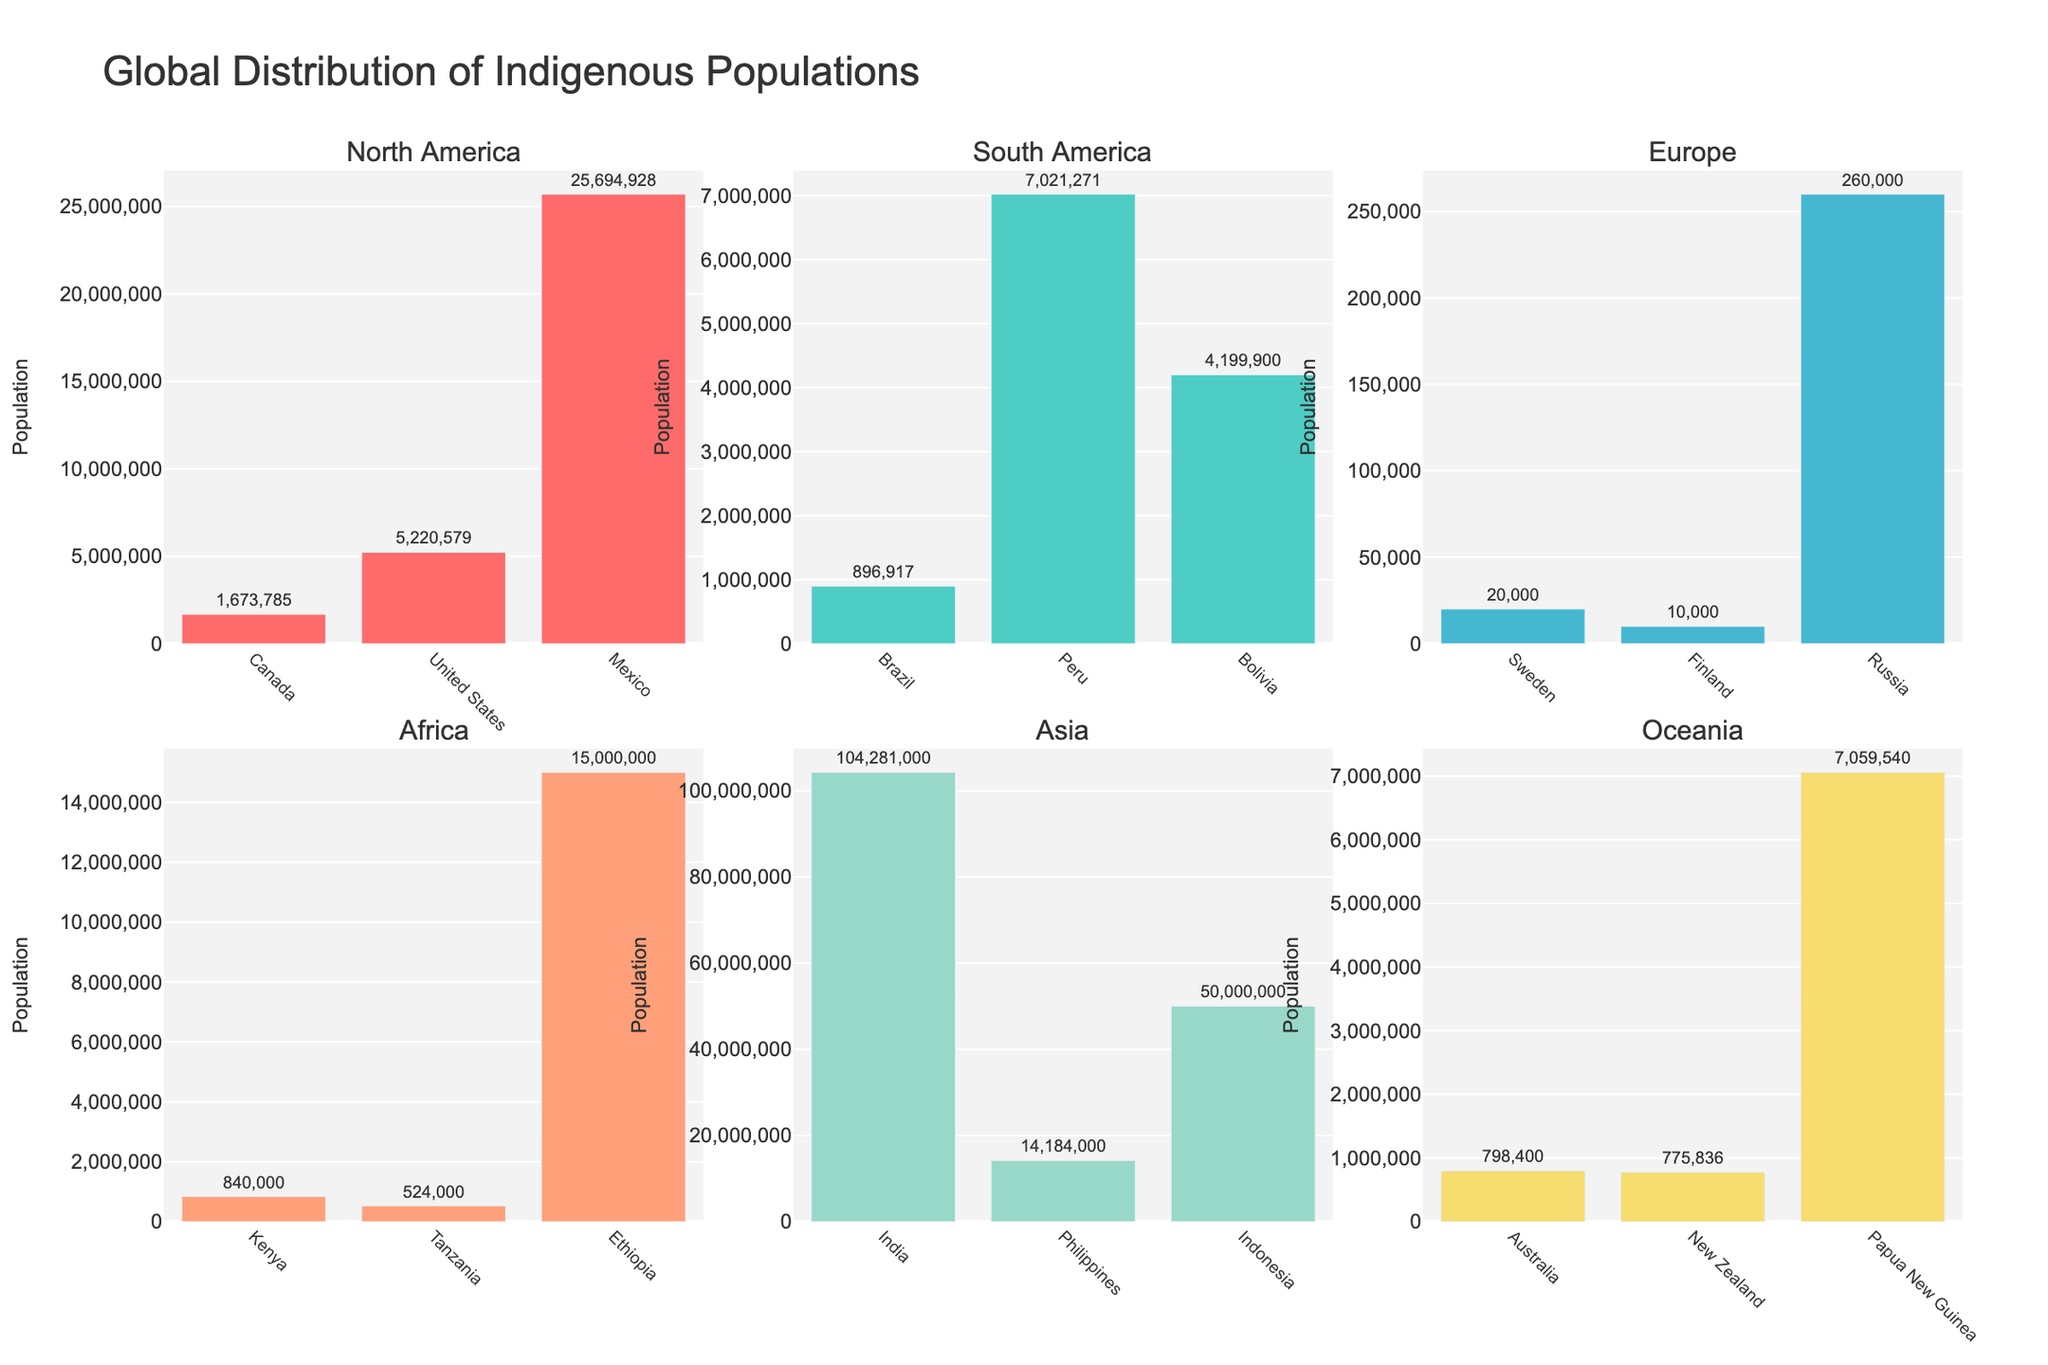What is the title of the figure? The title of the figure is usually found at the top and provides an overview of what the plot represents. In this case, the title is "Magical Realism Theater Productions Analysis".
Answer: Magical Realism Theater Productions Analysis How many productions are shown in the scatter plot? Each marker in the scatter plot corresponds to one production. By counting them, we see there are ten.
Answer: 10 Which production has the highest critical score? By examining the position of the markers and their labels, the production with the highest critical score is "The Master and Margarita" with a score of 94.
Answer: The Master and Margarita What is the city with the highest box office success? In the bar plot on the right, each bar represents box office success for different cities. The tallest bar for "Box Office Success" is for New York.
Answer: New York Which production has a higher box office success: "Like Water for Chocolate" or "Midnight's Children"? Compare the markers for both productions in the scatter plot. "Like Water for Chocolate" has a box office success of 81, and "Midnight's Children" has 73. Therefore, "Like Water for Chocolate" has higher success.
Answer: Like Water for Chocolate How does the critical score in Tokyo compare with that in London? The bar plot on the right shows the critical scores for different cities. Tokyo has a critical score of 83, while London has a score of 92.
Answer: London has a higher score What is the average box office success of the productions in the data? Calculate the sum of all box office successes and divide by the number of productions: (92 + 88 + 73 + 85 + 81 + 79 + 76 + 90 + 82 + 86) / 10 = 832 / 10.
Answer: 83.2 In which city did "The House of Spirits" perform, and what were its critical score and box office success? By referring to the labels and markers, we identify "The House of Spirits" performed in New York with a critical score of 85 and box office success of 92.
Answer: New York, 85, 92 What is the difference in box office success between the top two productions in terms of critical scores? The top two productions by critical scores are "The Master and Margarita" and "One Hundred Years of Solitude". Their box office successes are 90 and 88 respectively. The difference is 90 - 88.
Answer: 2 Which production in Berlin has the highest box office success? By checking the bar plot for the city "Berlin" and matching it with the production label in the scatter plot, we see "The Tin Drum" has the highest box office success in Berlin with a score of 85.
Answer: The Tin Drum 